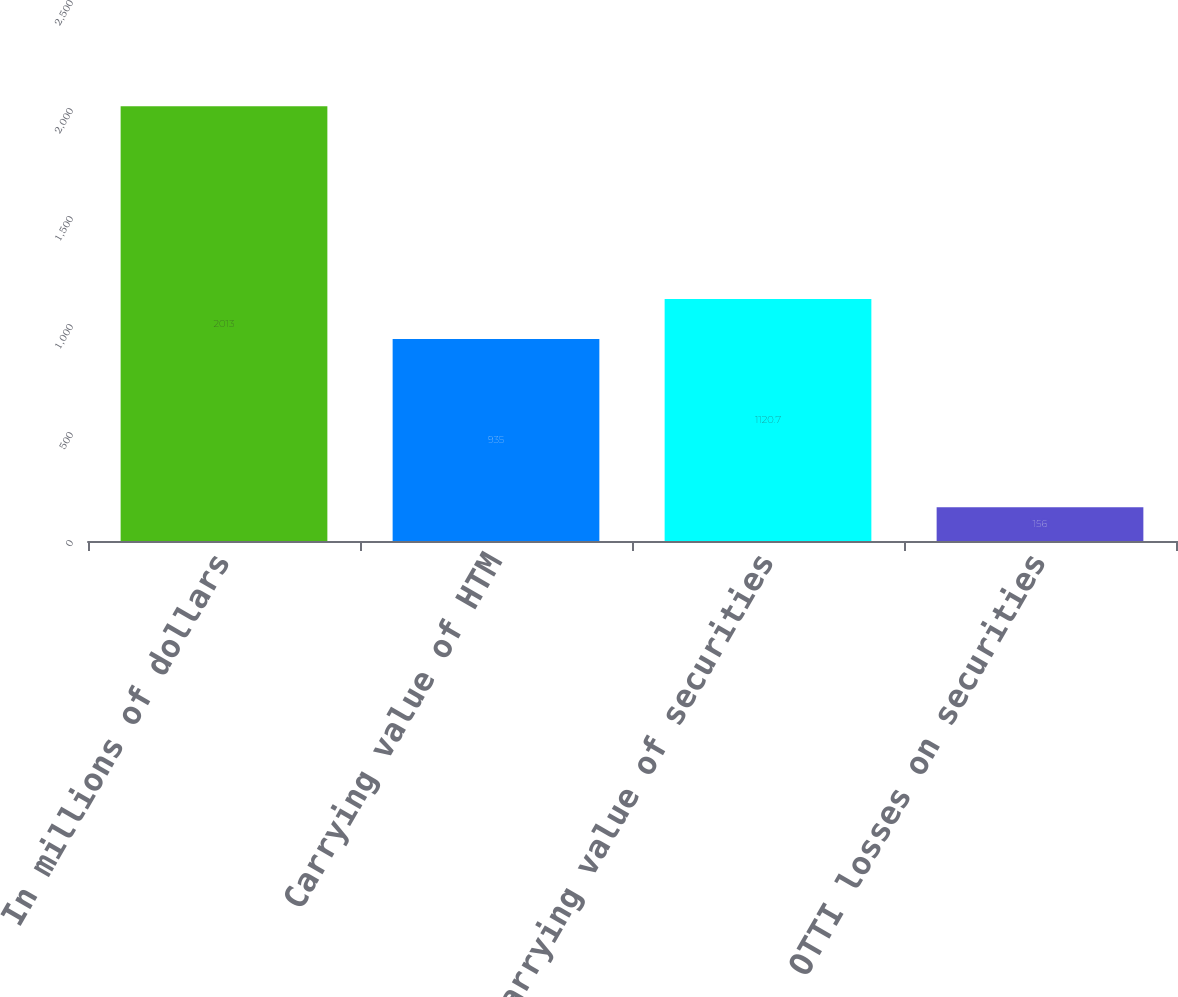<chart> <loc_0><loc_0><loc_500><loc_500><bar_chart><fcel>In millions of dollars<fcel>Carrying value of HTM<fcel>Carrying value of securities<fcel>OTTI losses on securities<nl><fcel>2013<fcel>935<fcel>1120.7<fcel>156<nl></chart> 